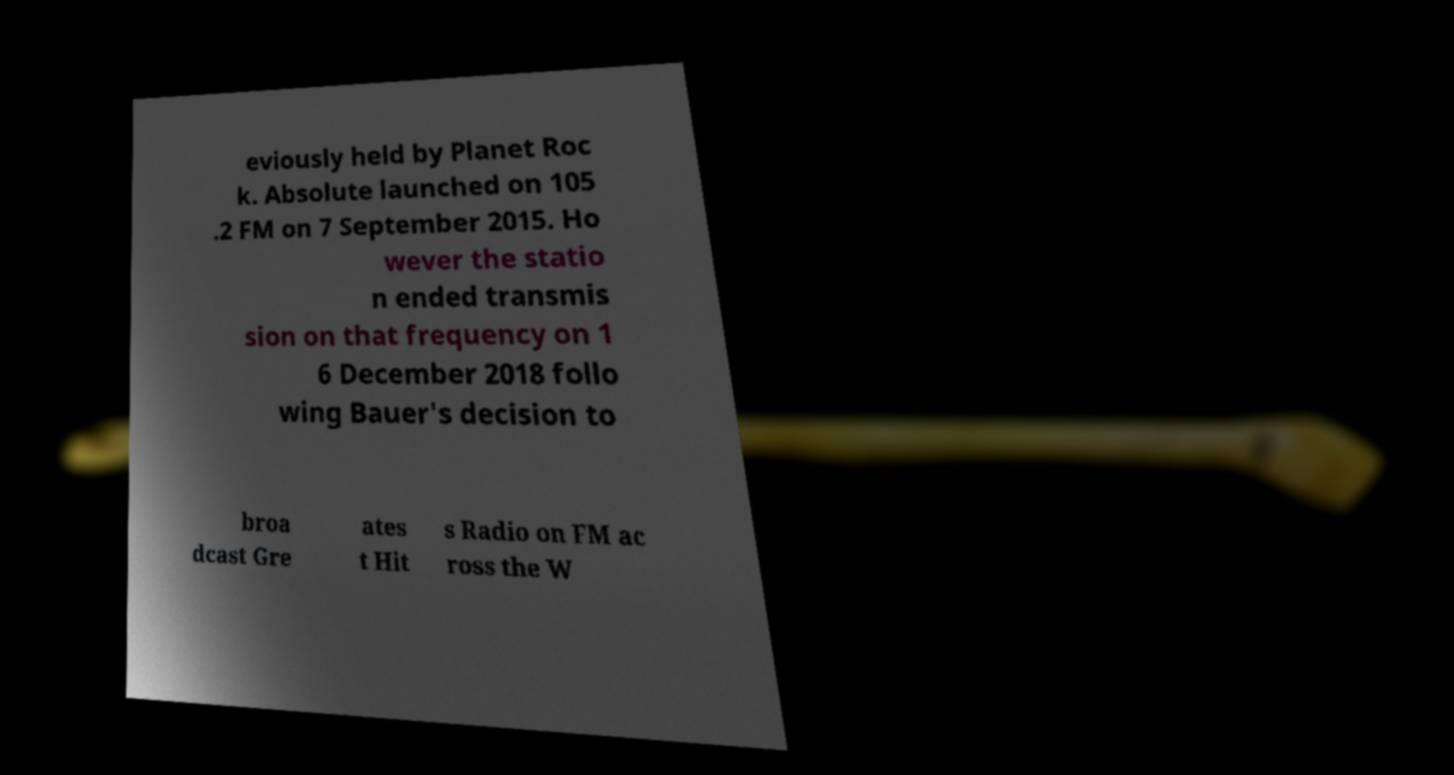Please read and relay the text visible in this image. What does it say? eviously held by Planet Roc k. Absolute launched on 105 .2 FM on 7 September 2015. Ho wever the statio n ended transmis sion on that frequency on 1 6 December 2018 follo wing Bauer's decision to broa dcast Gre ates t Hit s Radio on FM ac ross the W 